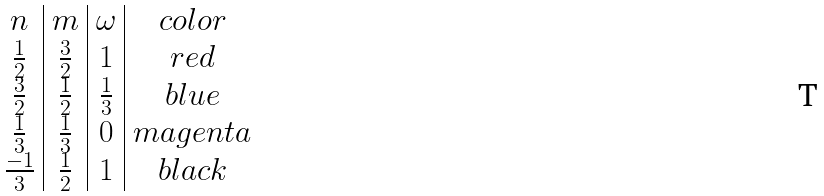<formula> <loc_0><loc_0><loc_500><loc_500>\begin{array} { c | c | c | c } n & m & \omega & c o l o r \\ \frac { 1 } { 2 } & \frac { 3 } { 2 } & 1 & r e d \\ \frac { 3 } { 2 } & \frac { 1 } { 2 } & \frac { 1 } { 3 } & b l u e \\ \frac { 1 } { 3 } & \frac { 1 } { 3 } & 0 & m a g e n t a \\ \frac { - 1 } { 3 } & \frac { 1 } { 2 } & 1 & b l a c k \end{array}</formula> 